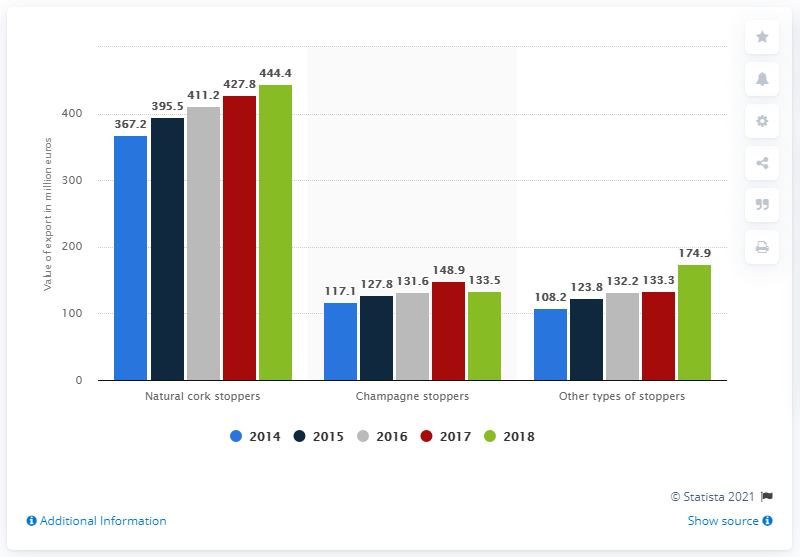Specify some key components in this picture. The total amount of champagne stoppers that were sold in 2018 was 133.5 million euros. 